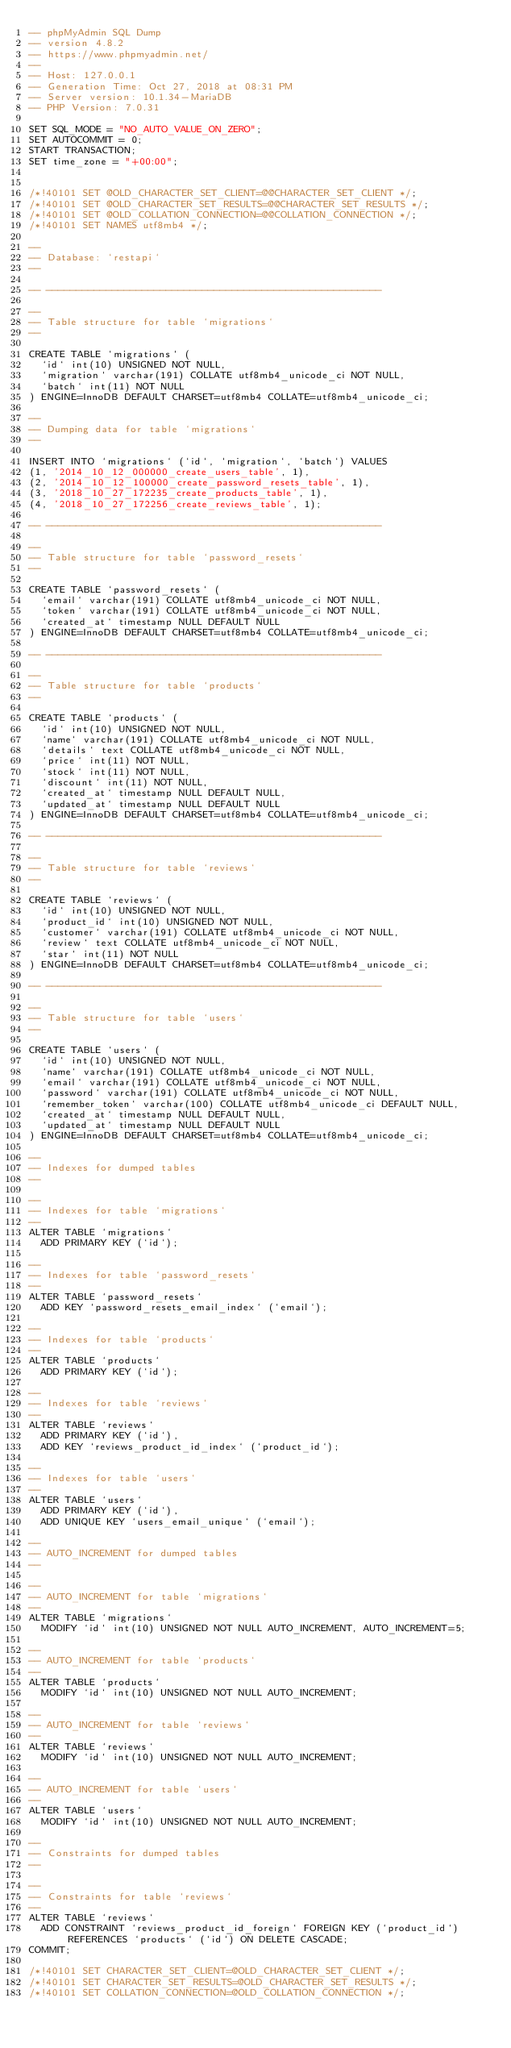<code> <loc_0><loc_0><loc_500><loc_500><_SQL_>-- phpMyAdmin SQL Dump
-- version 4.8.2
-- https://www.phpmyadmin.net/
--
-- Host: 127.0.0.1
-- Generation Time: Oct 27, 2018 at 08:31 PM
-- Server version: 10.1.34-MariaDB
-- PHP Version: 7.0.31

SET SQL_MODE = "NO_AUTO_VALUE_ON_ZERO";
SET AUTOCOMMIT = 0;
START TRANSACTION;
SET time_zone = "+00:00";


/*!40101 SET @OLD_CHARACTER_SET_CLIENT=@@CHARACTER_SET_CLIENT */;
/*!40101 SET @OLD_CHARACTER_SET_RESULTS=@@CHARACTER_SET_RESULTS */;
/*!40101 SET @OLD_COLLATION_CONNECTION=@@COLLATION_CONNECTION */;
/*!40101 SET NAMES utf8mb4 */;

--
-- Database: `restapi`
--

-- --------------------------------------------------------

--
-- Table structure for table `migrations`
--

CREATE TABLE `migrations` (
  `id` int(10) UNSIGNED NOT NULL,
  `migration` varchar(191) COLLATE utf8mb4_unicode_ci NOT NULL,
  `batch` int(11) NOT NULL
) ENGINE=InnoDB DEFAULT CHARSET=utf8mb4 COLLATE=utf8mb4_unicode_ci;

--
-- Dumping data for table `migrations`
--

INSERT INTO `migrations` (`id`, `migration`, `batch`) VALUES
(1, '2014_10_12_000000_create_users_table', 1),
(2, '2014_10_12_100000_create_password_resets_table', 1),
(3, '2018_10_27_172235_create_products_table', 1),
(4, '2018_10_27_172256_create_reviews_table', 1);

-- --------------------------------------------------------

--
-- Table structure for table `password_resets`
--

CREATE TABLE `password_resets` (
  `email` varchar(191) COLLATE utf8mb4_unicode_ci NOT NULL,
  `token` varchar(191) COLLATE utf8mb4_unicode_ci NOT NULL,
  `created_at` timestamp NULL DEFAULT NULL
) ENGINE=InnoDB DEFAULT CHARSET=utf8mb4 COLLATE=utf8mb4_unicode_ci;

-- --------------------------------------------------------

--
-- Table structure for table `products`
--

CREATE TABLE `products` (
  `id` int(10) UNSIGNED NOT NULL,
  `name` varchar(191) COLLATE utf8mb4_unicode_ci NOT NULL,
  `details` text COLLATE utf8mb4_unicode_ci NOT NULL,
  `price` int(11) NOT NULL,
  `stock` int(11) NOT NULL,
  `discount` int(11) NOT NULL,
  `created_at` timestamp NULL DEFAULT NULL,
  `updated_at` timestamp NULL DEFAULT NULL
) ENGINE=InnoDB DEFAULT CHARSET=utf8mb4 COLLATE=utf8mb4_unicode_ci;

-- --------------------------------------------------------

--
-- Table structure for table `reviews`
--

CREATE TABLE `reviews` (
  `id` int(10) UNSIGNED NOT NULL,
  `product_id` int(10) UNSIGNED NOT NULL,
  `customer` varchar(191) COLLATE utf8mb4_unicode_ci NOT NULL,
  `review` text COLLATE utf8mb4_unicode_ci NOT NULL,
  `star` int(11) NOT NULL
) ENGINE=InnoDB DEFAULT CHARSET=utf8mb4 COLLATE=utf8mb4_unicode_ci;

-- --------------------------------------------------------

--
-- Table structure for table `users`
--

CREATE TABLE `users` (
  `id` int(10) UNSIGNED NOT NULL,
  `name` varchar(191) COLLATE utf8mb4_unicode_ci NOT NULL,
  `email` varchar(191) COLLATE utf8mb4_unicode_ci NOT NULL,
  `password` varchar(191) COLLATE utf8mb4_unicode_ci NOT NULL,
  `remember_token` varchar(100) COLLATE utf8mb4_unicode_ci DEFAULT NULL,
  `created_at` timestamp NULL DEFAULT NULL,
  `updated_at` timestamp NULL DEFAULT NULL
) ENGINE=InnoDB DEFAULT CHARSET=utf8mb4 COLLATE=utf8mb4_unicode_ci;

--
-- Indexes for dumped tables
--

--
-- Indexes for table `migrations`
--
ALTER TABLE `migrations`
  ADD PRIMARY KEY (`id`);

--
-- Indexes for table `password_resets`
--
ALTER TABLE `password_resets`
  ADD KEY `password_resets_email_index` (`email`);

--
-- Indexes for table `products`
--
ALTER TABLE `products`
  ADD PRIMARY KEY (`id`);

--
-- Indexes for table `reviews`
--
ALTER TABLE `reviews`
  ADD PRIMARY KEY (`id`),
  ADD KEY `reviews_product_id_index` (`product_id`);

--
-- Indexes for table `users`
--
ALTER TABLE `users`
  ADD PRIMARY KEY (`id`),
  ADD UNIQUE KEY `users_email_unique` (`email`);

--
-- AUTO_INCREMENT for dumped tables
--

--
-- AUTO_INCREMENT for table `migrations`
--
ALTER TABLE `migrations`
  MODIFY `id` int(10) UNSIGNED NOT NULL AUTO_INCREMENT, AUTO_INCREMENT=5;

--
-- AUTO_INCREMENT for table `products`
--
ALTER TABLE `products`
  MODIFY `id` int(10) UNSIGNED NOT NULL AUTO_INCREMENT;

--
-- AUTO_INCREMENT for table `reviews`
--
ALTER TABLE `reviews`
  MODIFY `id` int(10) UNSIGNED NOT NULL AUTO_INCREMENT;

--
-- AUTO_INCREMENT for table `users`
--
ALTER TABLE `users`
  MODIFY `id` int(10) UNSIGNED NOT NULL AUTO_INCREMENT;

--
-- Constraints for dumped tables
--

--
-- Constraints for table `reviews`
--
ALTER TABLE `reviews`
  ADD CONSTRAINT `reviews_product_id_foreign` FOREIGN KEY (`product_id`) REFERENCES `products` (`id`) ON DELETE CASCADE;
COMMIT;

/*!40101 SET CHARACTER_SET_CLIENT=@OLD_CHARACTER_SET_CLIENT */;
/*!40101 SET CHARACTER_SET_RESULTS=@OLD_CHARACTER_SET_RESULTS */;
/*!40101 SET COLLATION_CONNECTION=@OLD_COLLATION_CONNECTION */;
</code> 